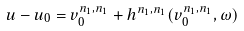<formula> <loc_0><loc_0><loc_500><loc_500>u - u _ { 0 } = v _ { 0 } ^ { n _ { 1 } , n _ { 1 } } + h ^ { n _ { 1 } , n _ { 1 } } ( v _ { 0 } ^ { n _ { 1 } , n _ { 1 } } , \omega )</formula> 